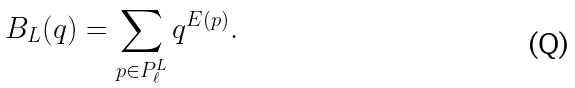<formula> <loc_0><loc_0><loc_500><loc_500>B _ { L } ( q ) = \sum _ { p \in { P } ^ { L } _ { \ell } } q ^ { E ( p ) } .</formula> 